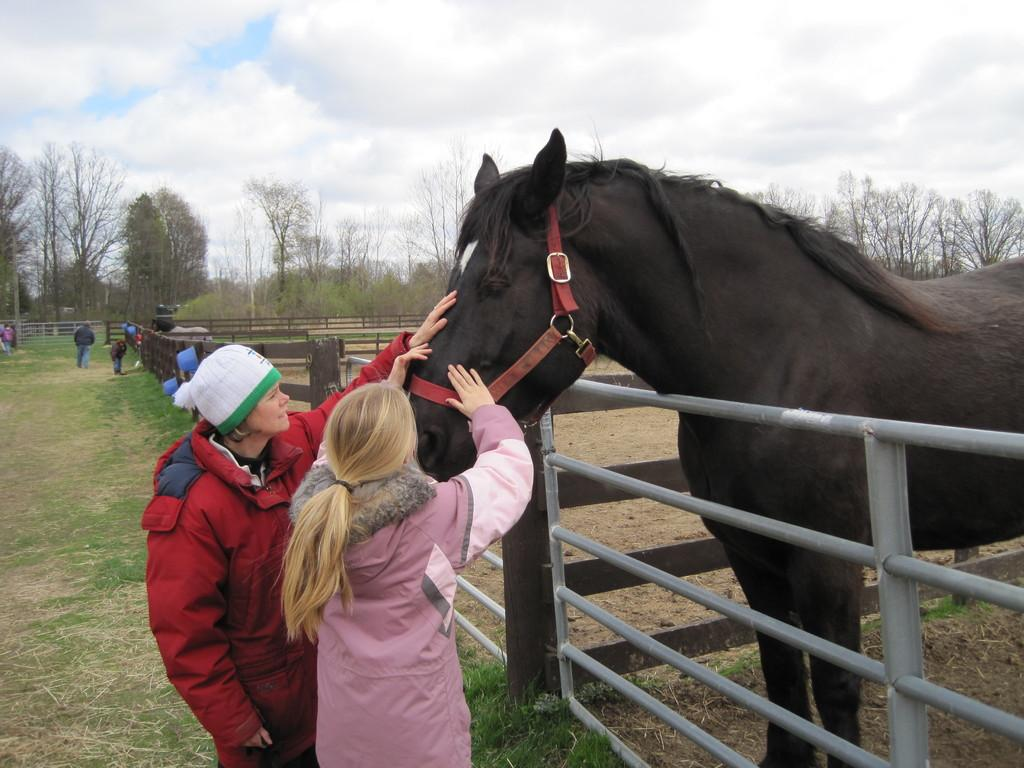How many people are in the image? There are two women in the image. What animal is present in the image? There is a black horse in the image. What are the women doing with the horse? The women are caressing the horse. How many oranges are being held by the horse's tongue in the image? There are no oranges or tongues visible in the image; it features two women caressing a black horse. 